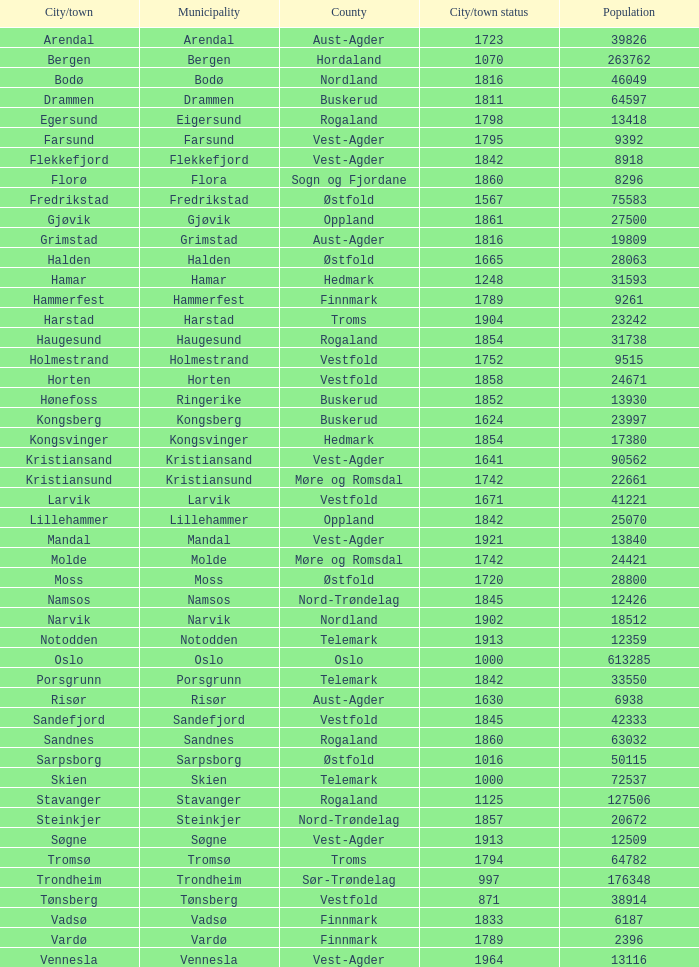What are the cities/towns located in the municipality of Moss? Moss. 